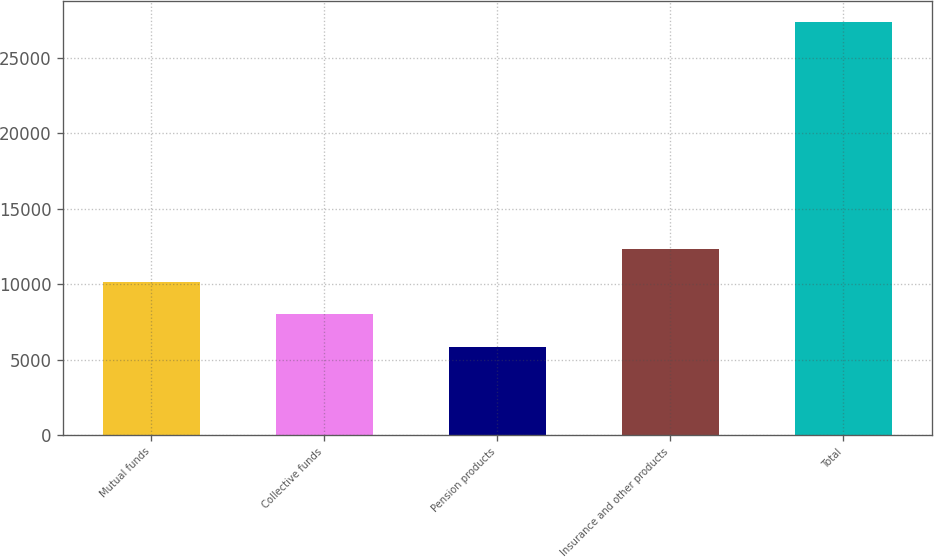<chart> <loc_0><loc_0><loc_500><loc_500><bar_chart><fcel>Mutual funds<fcel>Collective funds<fcel>Pension products<fcel>Insurance and other products<fcel>Total<nl><fcel>10166.2<fcel>8008.6<fcel>5851<fcel>12323.8<fcel>27427<nl></chart> 